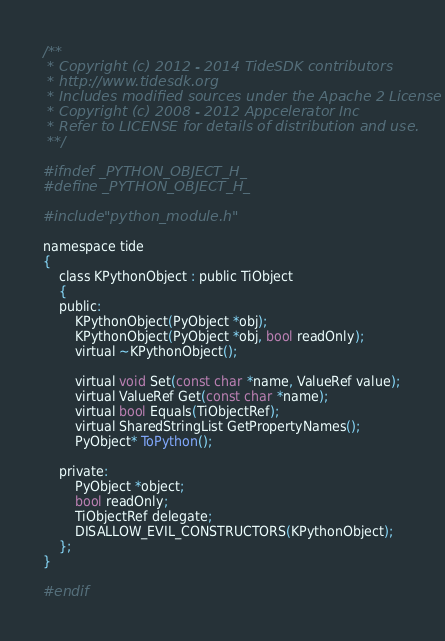<code> <loc_0><loc_0><loc_500><loc_500><_C_>/**
 * Copyright (c) 2012 - 2014 TideSDK contributors
 * http://www.tidesdk.org
 * Includes modified sources under the Apache 2 License
 * Copyright (c) 2008 - 2012 Appcelerator Inc
 * Refer to LICENSE for details of distribution and use.
 **/

#ifndef _PYTHON_OBJECT_H_
#define _PYTHON_OBJECT_H_

#include "python_module.h"

namespace tide
{
    class KPythonObject : public TiObject
    {
    public:
        KPythonObject(PyObject *obj);
        KPythonObject(PyObject *obj, bool readOnly);
        virtual ~KPythonObject();

        virtual void Set(const char *name, ValueRef value);
        virtual ValueRef Get(const char *name);
        virtual bool Equals(TiObjectRef);
        virtual SharedStringList GetPropertyNames();
        PyObject* ToPython();

    private:
        PyObject *object;
        bool readOnly;
        TiObjectRef delegate;
        DISALLOW_EVIL_CONSTRUCTORS(KPythonObject);
    };
}

#endif
</code> 